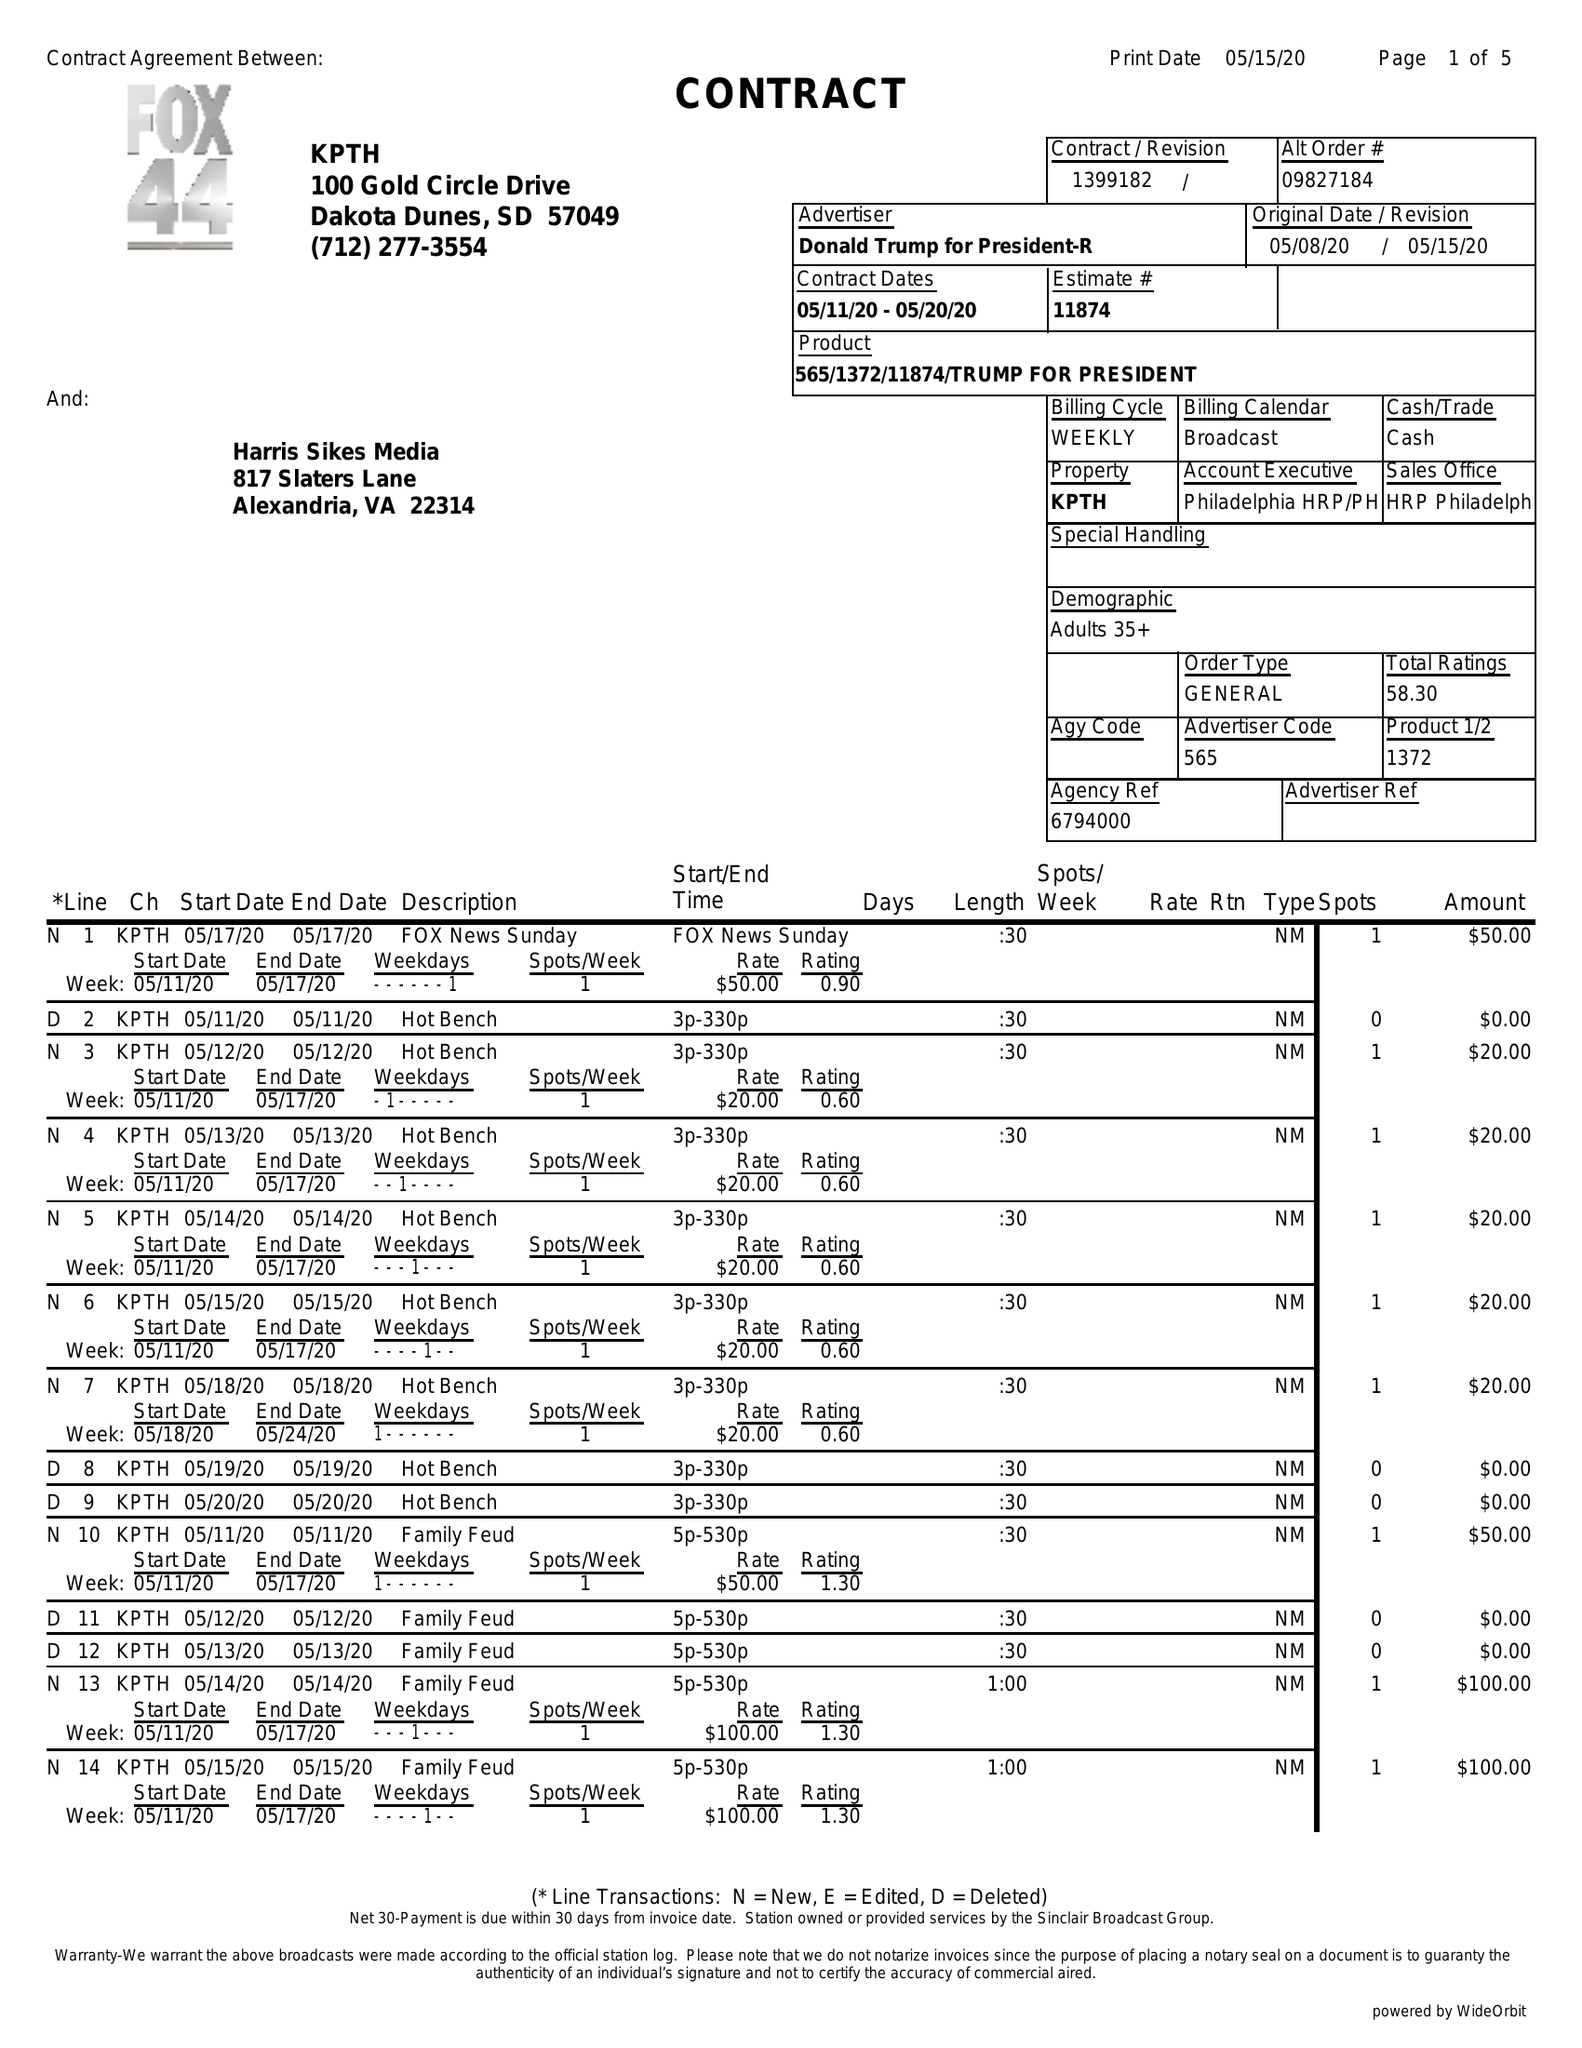What is the value for the gross_amount?
Answer the question using a single word or phrase. 3850.00 